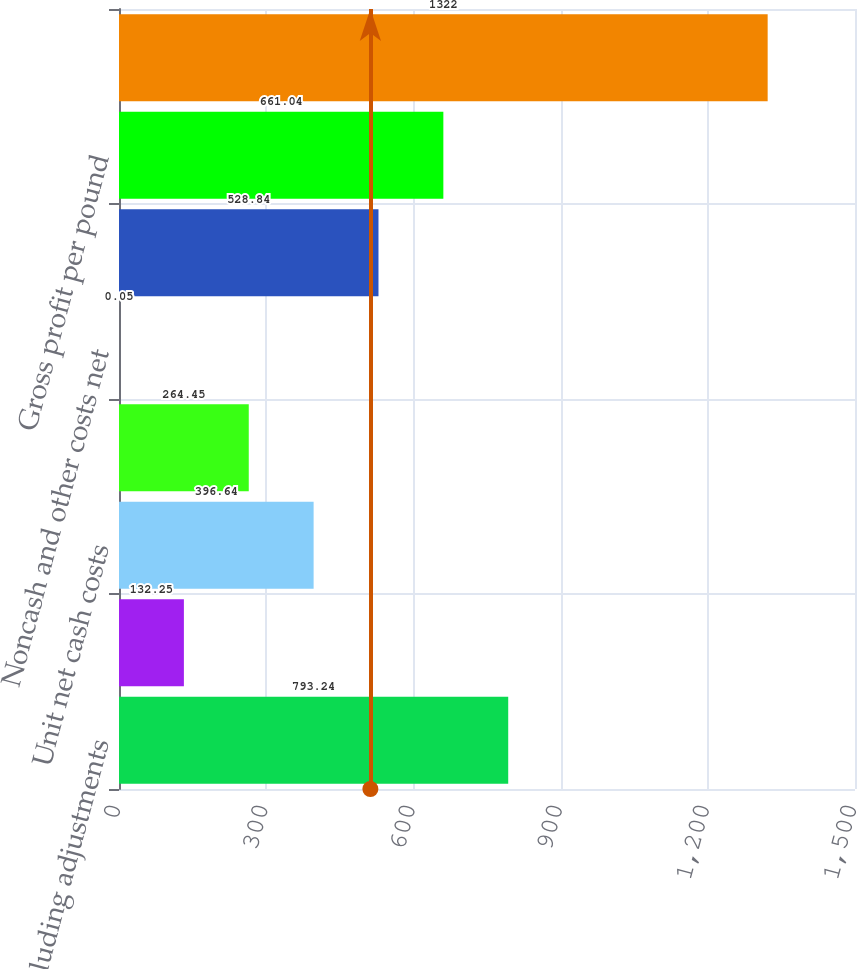Convert chart to OTSL. <chart><loc_0><loc_0><loc_500><loc_500><bar_chart><fcel>Revenues excluding adjustments<fcel>Treatment charges<fcel>Unit net cash costs<fcel>Depreciation depletion and<fcel>Noncash and other costs net<fcel>Total unit costs<fcel>Gross profit per pound<fcel>Copper sales (millions of<nl><fcel>793.24<fcel>132.25<fcel>396.64<fcel>264.45<fcel>0.05<fcel>528.84<fcel>661.04<fcel>1322<nl></chart> 